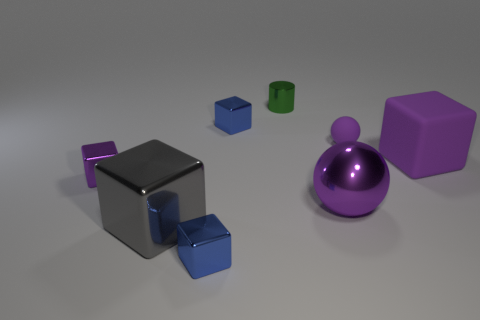Subtract all gray blocks. How many blocks are left? 4 Subtract all big gray blocks. How many blocks are left? 4 Subtract 3 blocks. How many blocks are left? 2 Subtract all cyan blocks. Subtract all gray spheres. How many blocks are left? 5 Add 2 large brown things. How many objects exist? 10 Subtract all cylinders. How many objects are left? 7 Subtract all brown metal spheres. Subtract all small metal things. How many objects are left? 4 Add 3 metal cubes. How many metal cubes are left? 7 Add 2 tiny red metal cylinders. How many tiny red metal cylinders exist? 2 Subtract 0 red spheres. How many objects are left? 8 